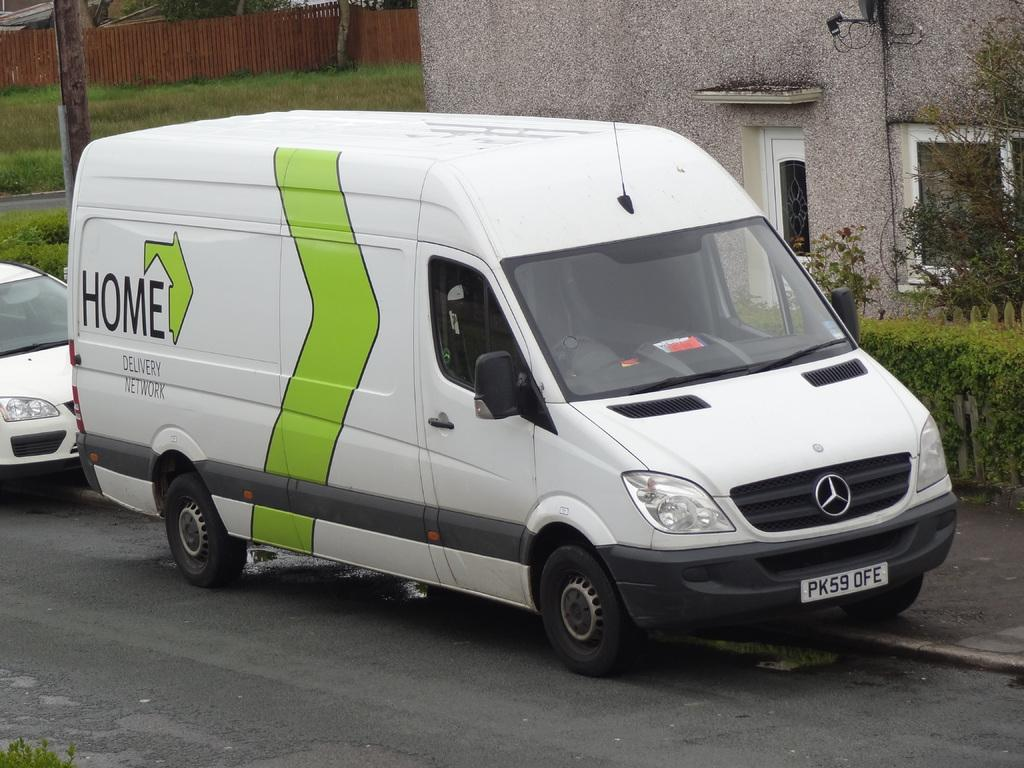<image>
Offer a succinct explanation of the picture presented. A Mercedes van for the Home Delivery Network. 